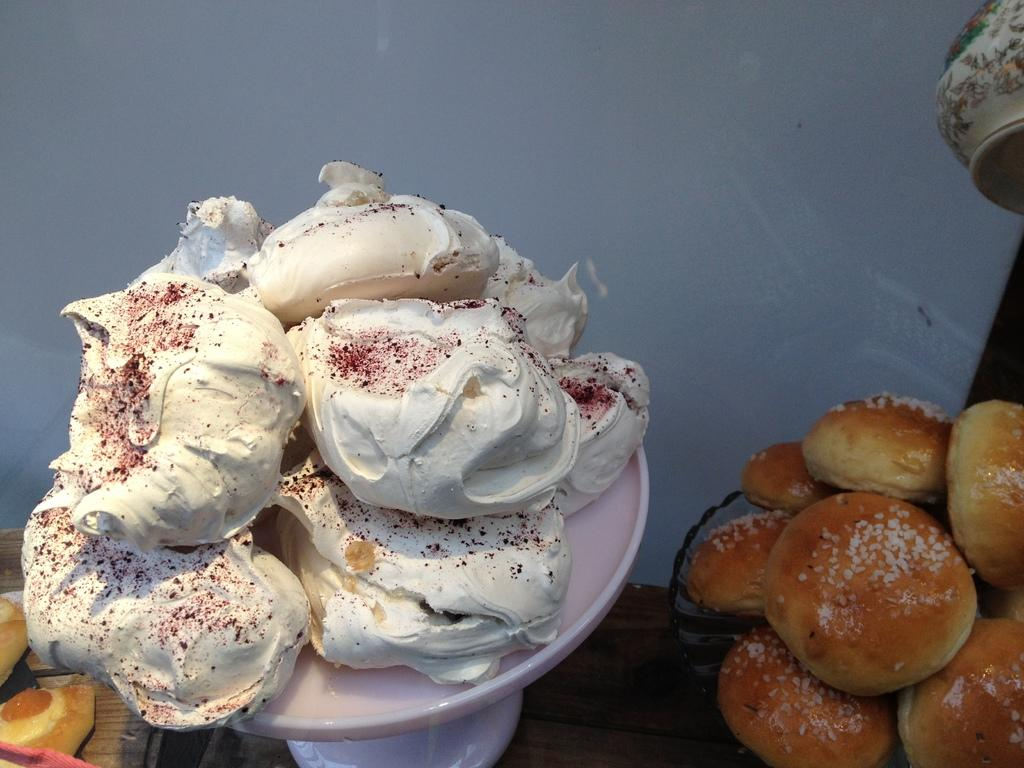What is the main food item in the image? There is ice cream in a bowl in the image. What other food items can be seen beside the bowl? There are small buns beside the bowl. What can be seen in the background of the image? There is a wall visible in the background of the image. What type of education is being offered by the door in the image? There is no door present in the image, so education cannot be offered by a door in this context. 